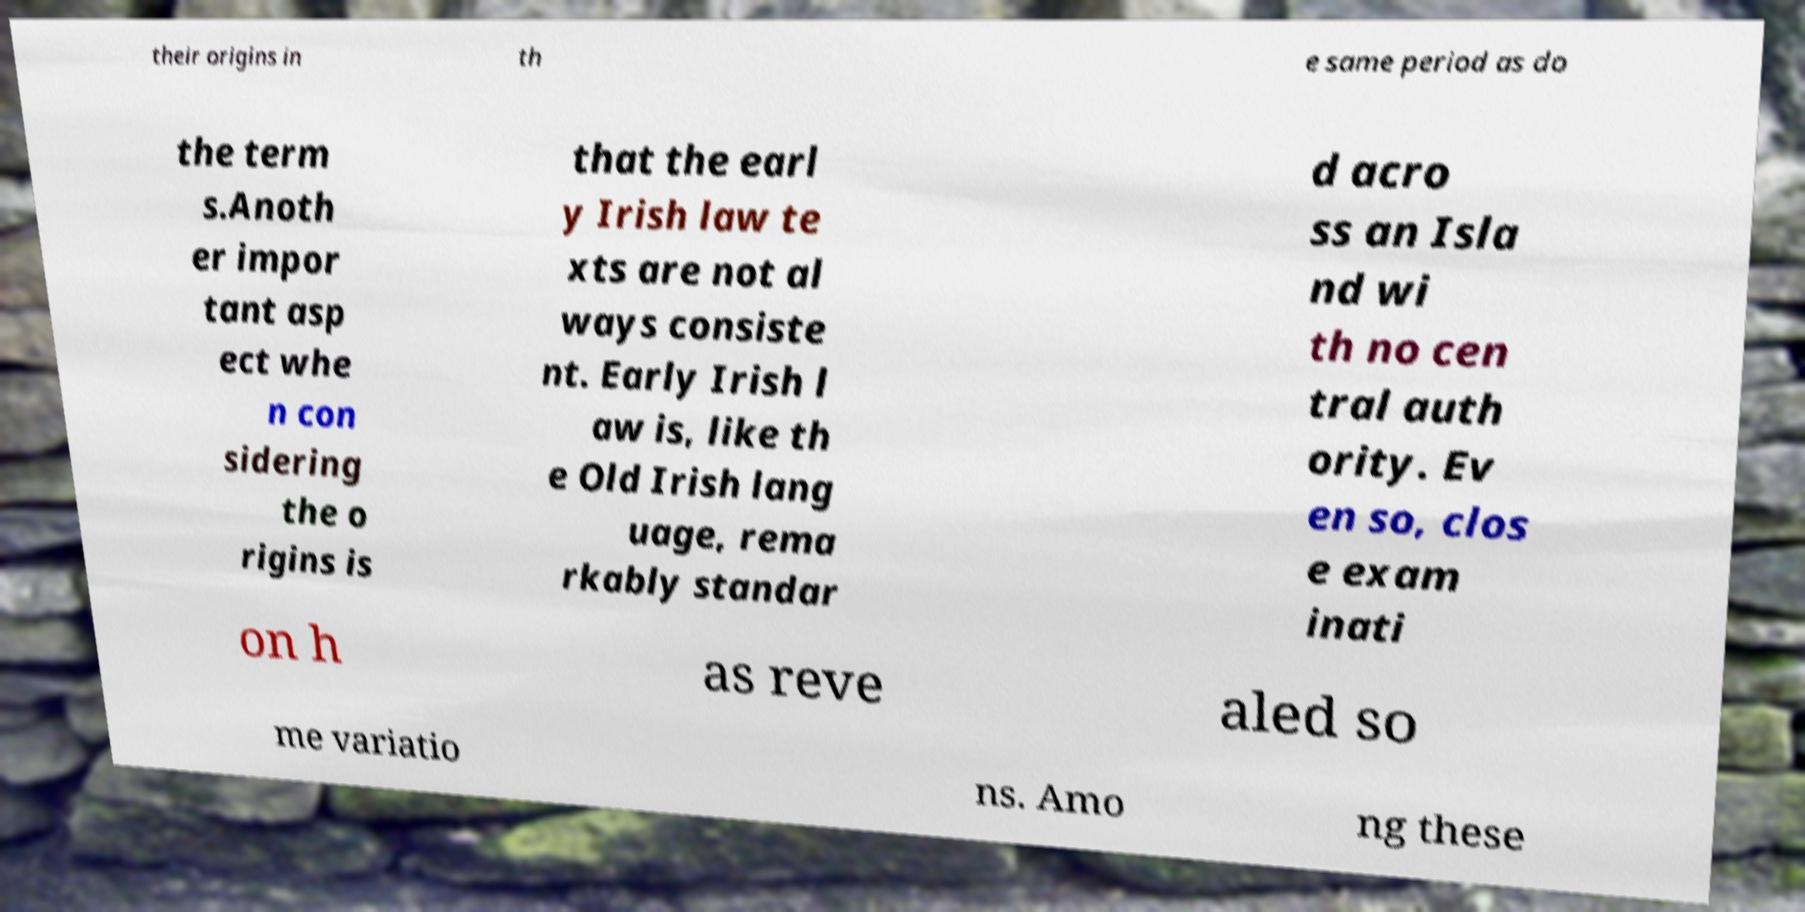For documentation purposes, I need the text within this image transcribed. Could you provide that? their origins in th e same period as do the term s.Anoth er impor tant asp ect whe n con sidering the o rigins is that the earl y Irish law te xts are not al ways consiste nt. Early Irish l aw is, like th e Old Irish lang uage, rema rkably standar d acro ss an Isla nd wi th no cen tral auth ority. Ev en so, clos e exam inati on h as reve aled so me variatio ns. Amo ng these 